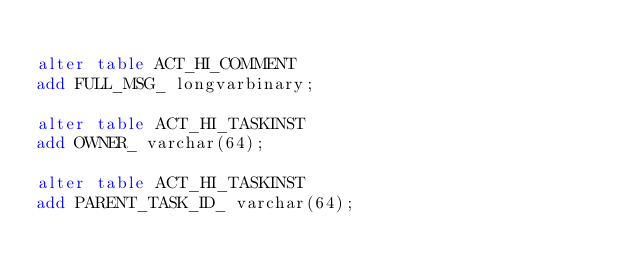<code> <loc_0><loc_0><loc_500><loc_500><_SQL_>
alter table ACT_HI_COMMENT 
add FULL_MSG_ longvarbinary;

alter table ACT_HI_TASKINST 
add OWNER_ varchar(64);

alter table ACT_HI_TASKINST 
add PARENT_TASK_ID_ varchar(64);
</code> 